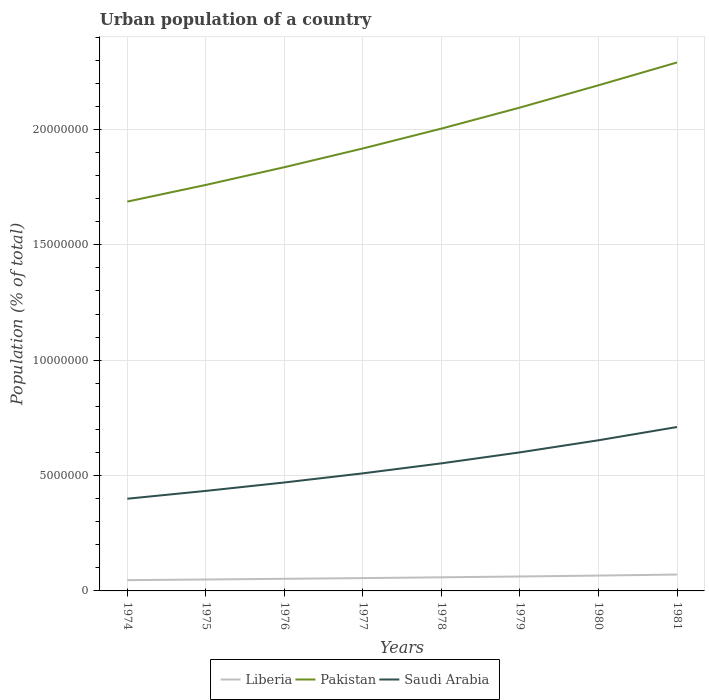How many different coloured lines are there?
Offer a terse response. 3. Does the line corresponding to Saudi Arabia intersect with the line corresponding to Pakistan?
Your answer should be compact. No. Is the number of lines equal to the number of legend labels?
Provide a short and direct response. Yes. Across all years, what is the maximum urban population in Liberia?
Make the answer very short. 4.66e+05. In which year was the urban population in Saudi Arabia maximum?
Your response must be concise. 1974. What is the total urban population in Saudi Arabia in the graph?
Make the answer very short. -7.61e+05. What is the difference between the highest and the second highest urban population in Pakistan?
Give a very brief answer. 6.03e+06. What is the difference between the highest and the lowest urban population in Saudi Arabia?
Ensure brevity in your answer.  4. Is the urban population in Liberia strictly greater than the urban population in Pakistan over the years?
Provide a short and direct response. Yes. How many years are there in the graph?
Offer a terse response. 8. What is the difference between two consecutive major ticks on the Y-axis?
Give a very brief answer. 5.00e+06. Are the values on the major ticks of Y-axis written in scientific E-notation?
Provide a short and direct response. No. Does the graph contain any zero values?
Provide a succinct answer. No. Where does the legend appear in the graph?
Your answer should be very brief. Bottom center. How many legend labels are there?
Your response must be concise. 3. How are the legend labels stacked?
Offer a very short reply. Horizontal. What is the title of the graph?
Your answer should be very brief. Urban population of a country. Does "Sweden" appear as one of the legend labels in the graph?
Provide a short and direct response. No. What is the label or title of the X-axis?
Keep it short and to the point. Years. What is the label or title of the Y-axis?
Offer a very short reply. Population (% of total). What is the Population (% of total) of Liberia in 1974?
Provide a short and direct response. 4.66e+05. What is the Population (% of total) of Pakistan in 1974?
Provide a succinct answer. 1.69e+07. What is the Population (% of total) in Saudi Arabia in 1974?
Keep it short and to the point. 4.00e+06. What is the Population (% of total) of Liberia in 1975?
Offer a very short reply. 4.95e+05. What is the Population (% of total) of Pakistan in 1975?
Make the answer very short. 1.76e+07. What is the Population (% of total) of Saudi Arabia in 1975?
Your response must be concise. 4.33e+06. What is the Population (% of total) of Liberia in 1976?
Offer a very short reply. 5.25e+05. What is the Population (% of total) in Pakistan in 1976?
Give a very brief answer. 1.84e+07. What is the Population (% of total) in Saudi Arabia in 1976?
Offer a very short reply. 4.70e+06. What is the Population (% of total) in Liberia in 1977?
Give a very brief answer. 5.56e+05. What is the Population (% of total) in Pakistan in 1977?
Offer a terse response. 1.92e+07. What is the Population (% of total) in Saudi Arabia in 1977?
Provide a succinct answer. 5.10e+06. What is the Population (% of total) in Liberia in 1978?
Your answer should be compact. 5.90e+05. What is the Population (% of total) of Pakistan in 1978?
Give a very brief answer. 2.00e+07. What is the Population (% of total) of Saudi Arabia in 1978?
Ensure brevity in your answer.  5.53e+06. What is the Population (% of total) in Liberia in 1979?
Your answer should be very brief. 6.26e+05. What is the Population (% of total) of Pakistan in 1979?
Give a very brief answer. 2.09e+07. What is the Population (% of total) in Saudi Arabia in 1979?
Your response must be concise. 6.00e+06. What is the Population (% of total) of Liberia in 1980?
Keep it short and to the point. 6.66e+05. What is the Population (% of total) of Pakistan in 1980?
Offer a terse response. 2.19e+07. What is the Population (% of total) of Saudi Arabia in 1980?
Make the answer very short. 6.53e+06. What is the Population (% of total) of Liberia in 1981?
Give a very brief answer. 7.09e+05. What is the Population (% of total) in Pakistan in 1981?
Your response must be concise. 2.29e+07. What is the Population (% of total) in Saudi Arabia in 1981?
Make the answer very short. 7.10e+06. Across all years, what is the maximum Population (% of total) in Liberia?
Your response must be concise. 7.09e+05. Across all years, what is the maximum Population (% of total) of Pakistan?
Offer a very short reply. 2.29e+07. Across all years, what is the maximum Population (% of total) of Saudi Arabia?
Make the answer very short. 7.10e+06. Across all years, what is the minimum Population (% of total) of Liberia?
Provide a succinct answer. 4.66e+05. Across all years, what is the minimum Population (% of total) of Pakistan?
Offer a very short reply. 1.69e+07. Across all years, what is the minimum Population (% of total) of Saudi Arabia?
Your response must be concise. 4.00e+06. What is the total Population (% of total) in Liberia in the graph?
Ensure brevity in your answer.  4.63e+06. What is the total Population (% of total) in Pakistan in the graph?
Provide a succinct answer. 1.58e+08. What is the total Population (% of total) in Saudi Arabia in the graph?
Your response must be concise. 4.33e+07. What is the difference between the Population (% of total) in Liberia in 1974 and that in 1975?
Offer a very short reply. -2.84e+04. What is the difference between the Population (% of total) in Pakistan in 1974 and that in 1975?
Offer a very short reply. -7.23e+05. What is the difference between the Population (% of total) in Saudi Arabia in 1974 and that in 1975?
Your answer should be very brief. -3.40e+05. What is the difference between the Population (% of total) in Liberia in 1974 and that in 1976?
Provide a succinct answer. -5.84e+04. What is the difference between the Population (% of total) of Pakistan in 1974 and that in 1976?
Offer a terse response. -1.49e+06. What is the difference between the Population (% of total) in Saudi Arabia in 1974 and that in 1976?
Your answer should be compact. -7.04e+05. What is the difference between the Population (% of total) of Liberia in 1974 and that in 1977?
Give a very brief answer. -8.97e+04. What is the difference between the Population (% of total) of Pakistan in 1974 and that in 1977?
Make the answer very short. -2.30e+06. What is the difference between the Population (% of total) in Saudi Arabia in 1974 and that in 1977?
Your answer should be very brief. -1.10e+06. What is the difference between the Population (% of total) in Liberia in 1974 and that in 1978?
Provide a succinct answer. -1.23e+05. What is the difference between the Population (% of total) of Pakistan in 1974 and that in 1978?
Keep it short and to the point. -3.16e+06. What is the difference between the Population (% of total) of Saudi Arabia in 1974 and that in 1978?
Offer a very short reply. -1.53e+06. What is the difference between the Population (% of total) of Liberia in 1974 and that in 1979?
Provide a short and direct response. -1.59e+05. What is the difference between the Population (% of total) in Pakistan in 1974 and that in 1979?
Provide a short and direct response. -4.08e+06. What is the difference between the Population (% of total) in Saudi Arabia in 1974 and that in 1979?
Provide a short and direct response. -2.01e+06. What is the difference between the Population (% of total) in Liberia in 1974 and that in 1980?
Offer a terse response. -1.99e+05. What is the difference between the Population (% of total) in Pakistan in 1974 and that in 1980?
Keep it short and to the point. -5.04e+06. What is the difference between the Population (% of total) in Saudi Arabia in 1974 and that in 1980?
Your answer should be compact. -2.53e+06. What is the difference between the Population (% of total) in Liberia in 1974 and that in 1981?
Offer a terse response. -2.43e+05. What is the difference between the Population (% of total) of Pakistan in 1974 and that in 1981?
Offer a very short reply. -6.03e+06. What is the difference between the Population (% of total) of Saudi Arabia in 1974 and that in 1981?
Your response must be concise. -3.11e+06. What is the difference between the Population (% of total) of Liberia in 1975 and that in 1976?
Make the answer very short. -3.00e+04. What is the difference between the Population (% of total) of Pakistan in 1975 and that in 1976?
Offer a very short reply. -7.68e+05. What is the difference between the Population (% of total) in Saudi Arabia in 1975 and that in 1976?
Provide a short and direct response. -3.65e+05. What is the difference between the Population (% of total) of Liberia in 1975 and that in 1977?
Make the answer very short. -6.13e+04. What is the difference between the Population (% of total) in Pakistan in 1975 and that in 1977?
Ensure brevity in your answer.  -1.58e+06. What is the difference between the Population (% of total) in Saudi Arabia in 1975 and that in 1977?
Your response must be concise. -7.61e+05. What is the difference between the Population (% of total) in Liberia in 1975 and that in 1978?
Give a very brief answer. -9.47e+04. What is the difference between the Population (% of total) of Pakistan in 1975 and that in 1978?
Provide a succinct answer. -2.44e+06. What is the difference between the Population (% of total) of Saudi Arabia in 1975 and that in 1978?
Your answer should be very brief. -1.19e+06. What is the difference between the Population (% of total) of Liberia in 1975 and that in 1979?
Offer a terse response. -1.31e+05. What is the difference between the Population (% of total) in Pakistan in 1975 and that in 1979?
Keep it short and to the point. -3.35e+06. What is the difference between the Population (% of total) of Saudi Arabia in 1975 and that in 1979?
Make the answer very short. -1.67e+06. What is the difference between the Population (% of total) in Liberia in 1975 and that in 1980?
Offer a terse response. -1.71e+05. What is the difference between the Population (% of total) in Pakistan in 1975 and that in 1980?
Offer a very short reply. -4.32e+06. What is the difference between the Population (% of total) in Saudi Arabia in 1975 and that in 1980?
Your answer should be compact. -2.19e+06. What is the difference between the Population (% of total) in Liberia in 1975 and that in 1981?
Your answer should be very brief. -2.15e+05. What is the difference between the Population (% of total) in Pakistan in 1975 and that in 1981?
Give a very brief answer. -5.31e+06. What is the difference between the Population (% of total) in Saudi Arabia in 1975 and that in 1981?
Provide a short and direct response. -2.77e+06. What is the difference between the Population (% of total) in Liberia in 1976 and that in 1977?
Offer a terse response. -3.13e+04. What is the difference between the Population (% of total) in Pakistan in 1976 and that in 1977?
Ensure brevity in your answer.  -8.12e+05. What is the difference between the Population (% of total) of Saudi Arabia in 1976 and that in 1977?
Offer a terse response. -3.96e+05. What is the difference between the Population (% of total) of Liberia in 1976 and that in 1978?
Give a very brief answer. -6.47e+04. What is the difference between the Population (% of total) of Pakistan in 1976 and that in 1978?
Your answer should be compact. -1.67e+06. What is the difference between the Population (% of total) of Saudi Arabia in 1976 and that in 1978?
Your response must be concise. -8.29e+05. What is the difference between the Population (% of total) in Liberia in 1976 and that in 1979?
Make the answer very short. -1.01e+05. What is the difference between the Population (% of total) in Pakistan in 1976 and that in 1979?
Provide a short and direct response. -2.58e+06. What is the difference between the Population (% of total) of Saudi Arabia in 1976 and that in 1979?
Your answer should be very brief. -1.31e+06. What is the difference between the Population (% of total) in Liberia in 1976 and that in 1980?
Give a very brief answer. -1.41e+05. What is the difference between the Population (% of total) in Pakistan in 1976 and that in 1980?
Keep it short and to the point. -3.55e+06. What is the difference between the Population (% of total) in Saudi Arabia in 1976 and that in 1980?
Give a very brief answer. -1.83e+06. What is the difference between the Population (% of total) in Liberia in 1976 and that in 1981?
Offer a very short reply. -1.85e+05. What is the difference between the Population (% of total) in Pakistan in 1976 and that in 1981?
Your answer should be compact. -4.54e+06. What is the difference between the Population (% of total) in Saudi Arabia in 1976 and that in 1981?
Provide a short and direct response. -2.40e+06. What is the difference between the Population (% of total) of Liberia in 1977 and that in 1978?
Ensure brevity in your answer.  -3.34e+04. What is the difference between the Population (% of total) in Pakistan in 1977 and that in 1978?
Keep it short and to the point. -8.61e+05. What is the difference between the Population (% of total) in Saudi Arabia in 1977 and that in 1978?
Provide a short and direct response. -4.33e+05. What is the difference between the Population (% of total) of Liberia in 1977 and that in 1979?
Provide a succinct answer. -6.97e+04. What is the difference between the Population (% of total) in Pakistan in 1977 and that in 1979?
Offer a terse response. -1.77e+06. What is the difference between the Population (% of total) of Saudi Arabia in 1977 and that in 1979?
Offer a very short reply. -9.10e+05. What is the difference between the Population (% of total) in Liberia in 1977 and that in 1980?
Offer a very short reply. -1.09e+05. What is the difference between the Population (% of total) of Pakistan in 1977 and that in 1980?
Make the answer very short. -2.74e+06. What is the difference between the Population (% of total) of Saudi Arabia in 1977 and that in 1980?
Offer a terse response. -1.43e+06. What is the difference between the Population (% of total) of Liberia in 1977 and that in 1981?
Give a very brief answer. -1.53e+05. What is the difference between the Population (% of total) of Pakistan in 1977 and that in 1981?
Give a very brief answer. -3.73e+06. What is the difference between the Population (% of total) of Saudi Arabia in 1977 and that in 1981?
Provide a succinct answer. -2.01e+06. What is the difference between the Population (% of total) of Liberia in 1978 and that in 1979?
Make the answer very short. -3.63e+04. What is the difference between the Population (% of total) in Pakistan in 1978 and that in 1979?
Your response must be concise. -9.11e+05. What is the difference between the Population (% of total) in Saudi Arabia in 1978 and that in 1979?
Keep it short and to the point. -4.76e+05. What is the difference between the Population (% of total) of Liberia in 1978 and that in 1980?
Keep it short and to the point. -7.60e+04. What is the difference between the Population (% of total) of Pakistan in 1978 and that in 1980?
Provide a succinct answer. -1.88e+06. What is the difference between the Population (% of total) of Saudi Arabia in 1978 and that in 1980?
Your answer should be compact. -1.00e+06. What is the difference between the Population (% of total) of Liberia in 1978 and that in 1981?
Keep it short and to the point. -1.20e+05. What is the difference between the Population (% of total) of Pakistan in 1978 and that in 1981?
Keep it short and to the point. -2.87e+06. What is the difference between the Population (% of total) of Saudi Arabia in 1978 and that in 1981?
Ensure brevity in your answer.  -1.57e+06. What is the difference between the Population (% of total) of Liberia in 1979 and that in 1980?
Provide a succinct answer. -3.97e+04. What is the difference between the Population (% of total) in Pakistan in 1979 and that in 1980?
Keep it short and to the point. -9.66e+05. What is the difference between the Population (% of total) in Saudi Arabia in 1979 and that in 1980?
Your response must be concise. -5.24e+05. What is the difference between the Population (% of total) of Liberia in 1979 and that in 1981?
Offer a terse response. -8.36e+04. What is the difference between the Population (% of total) of Pakistan in 1979 and that in 1981?
Give a very brief answer. -1.95e+06. What is the difference between the Population (% of total) in Saudi Arabia in 1979 and that in 1981?
Your answer should be very brief. -1.10e+06. What is the difference between the Population (% of total) in Liberia in 1980 and that in 1981?
Provide a short and direct response. -4.39e+04. What is the difference between the Population (% of total) in Pakistan in 1980 and that in 1981?
Offer a very short reply. -9.89e+05. What is the difference between the Population (% of total) of Saudi Arabia in 1980 and that in 1981?
Provide a succinct answer. -5.74e+05. What is the difference between the Population (% of total) of Liberia in 1974 and the Population (% of total) of Pakistan in 1975?
Offer a very short reply. -1.71e+07. What is the difference between the Population (% of total) of Liberia in 1974 and the Population (% of total) of Saudi Arabia in 1975?
Offer a terse response. -3.87e+06. What is the difference between the Population (% of total) in Pakistan in 1974 and the Population (% of total) in Saudi Arabia in 1975?
Ensure brevity in your answer.  1.25e+07. What is the difference between the Population (% of total) of Liberia in 1974 and the Population (% of total) of Pakistan in 1976?
Your answer should be compact. -1.79e+07. What is the difference between the Population (% of total) in Liberia in 1974 and the Population (% of total) in Saudi Arabia in 1976?
Your answer should be compact. -4.23e+06. What is the difference between the Population (% of total) of Pakistan in 1974 and the Population (% of total) of Saudi Arabia in 1976?
Keep it short and to the point. 1.22e+07. What is the difference between the Population (% of total) of Liberia in 1974 and the Population (% of total) of Pakistan in 1977?
Offer a very short reply. -1.87e+07. What is the difference between the Population (% of total) in Liberia in 1974 and the Population (% of total) in Saudi Arabia in 1977?
Offer a very short reply. -4.63e+06. What is the difference between the Population (% of total) in Pakistan in 1974 and the Population (% of total) in Saudi Arabia in 1977?
Provide a succinct answer. 1.18e+07. What is the difference between the Population (% of total) of Liberia in 1974 and the Population (% of total) of Pakistan in 1978?
Offer a terse response. -1.96e+07. What is the difference between the Population (% of total) in Liberia in 1974 and the Population (% of total) in Saudi Arabia in 1978?
Give a very brief answer. -5.06e+06. What is the difference between the Population (% of total) in Pakistan in 1974 and the Population (% of total) in Saudi Arabia in 1978?
Ensure brevity in your answer.  1.13e+07. What is the difference between the Population (% of total) in Liberia in 1974 and the Population (% of total) in Pakistan in 1979?
Ensure brevity in your answer.  -2.05e+07. What is the difference between the Population (% of total) in Liberia in 1974 and the Population (% of total) in Saudi Arabia in 1979?
Keep it short and to the point. -5.54e+06. What is the difference between the Population (% of total) of Pakistan in 1974 and the Population (% of total) of Saudi Arabia in 1979?
Offer a terse response. 1.09e+07. What is the difference between the Population (% of total) of Liberia in 1974 and the Population (% of total) of Pakistan in 1980?
Your answer should be very brief. -2.14e+07. What is the difference between the Population (% of total) in Liberia in 1974 and the Population (% of total) in Saudi Arabia in 1980?
Make the answer very short. -6.06e+06. What is the difference between the Population (% of total) in Pakistan in 1974 and the Population (% of total) in Saudi Arabia in 1980?
Provide a short and direct response. 1.03e+07. What is the difference between the Population (% of total) in Liberia in 1974 and the Population (% of total) in Pakistan in 1981?
Give a very brief answer. -2.24e+07. What is the difference between the Population (% of total) of Liberia in 1974 and the Population (% of total) of Saudi Arabia in 1981?
Offer a terse response. -6.64e+06. What is the difference between the Population (% of total) in Pakistan in 1974 and the Population (% of total) in Saudi Arabia in 1981?
Your response must be concise. 9.77e+06. What is the difference between the Population (% of total) in Liberia in 1975 and the Population (% of total) in Pakistan in 1976?
Offer a very short reply. -1.79e+07. What is the difference between the Population (% of total) in Liberia in 1975 and the Population (% of total) in Saudi Arabia in 1976?
Keep it short and to the point. -4.20e+06. What is the difference between the Population (% of total) of Pakistan in 1975 and the Population (% of total) of Saudi Arabia in 1976?
Provide a succinct answer. 1.29e+07. What is the difference between the Population (% of total) in Liberia in 1975 and the Population (% of total) in Pakistan in 1977?
Your answer should be compact. -1.87e+07. What is the difference between the Population (% of total) in Liberia in 1975 and the Population (% of total) in Saudi Arabia in 1977?
Ensure brevity in your answer.  -4.60e+06. What is the difference between the Population (% of total) in Pakistan in 1975 and the Population (% of total) in Saudi Arabia in 1977?
Give a very brief answer. 1.25e+07. What is the difference between the Population (% of total) of Liberia in 1975 and the Population (% of total) of Pakistan in 1978?
Give a very brief answer. -1.95e+07. What is the difference between the Population (% of total) of Liberia in 1975 and the Population (% of total) of Saudi Arabia in 1978?
Offer a very short reply. -5.03e+06. What is the difference between the Population (% of total) of Pakistan in 1975 and the Population (% of total) of Saudi Arabia in 1978?
Provide a short and direct response. 1.21e+07. What is the difference between the Population (% of total) in Liberia in 1975 and the Population (% of total) in Pakistan in 1979?
Your answer should be very brief. -2.05e+07. What is the difference between the Population (% of total) in Liberia in 1975 and the Population (% of total) in Saudi Arabia in 1979?
Your answer should be compact. -5.51e+06. What is the difference between the Population (% of total) of Pakistan in 1975 and the Population (% of total) of Saudi Arabia in 1979?
Offer a very short reply. 1.16e+07. What is the difference between the Population (% of total) in Liberia in 1975 and the Population (% of total) in Pakistan in 1980?
Ensure brevity in your answer.  -2.14e+07. What is the difference between the Population (% of total) in Liberia in 1975 and the Population (% of total) in Saudi Arabia in 1980?
Provide a succinct answer. -6.03e+06. What is the difference between the Population (% of total) of Pakistan in 1975 and the Population (% of total) of Saudi Arabia in 1980?
Your response must be concise. 1.11e+07. What is the difference between the Population (% of total) in Liberia in 1975 and the Population (% of total) in Pakistan in 1981?
Your answer should be very brief. -2.24e+07. What is the difference between the Population (% of total) in Liberia in 1975 and the Population (% of total) in Saudi Arabia in 1981?
Ensure brevity in your answer.  -6.61e+06. What is the difference between the Population (% of total) of Pakistan in 1975 and the Population (% of total) of Saudi Arabia in 1981?
Provide a short and direct response. 1.05e+07. What is the difference between the Population (% of total) of Liberia in 1976 and the Population (% of total) of Pakistan in 1977?
Your answer should be very brief. -1.86e+07. What is the difference between the Population (% of total) of Liberia in 1976 and the Population (% of total) of Saudi Arabia in 1977?
Offer a terse response. -4.57e+06. What is the difference between the Population (% of total) of Pakistan in 1976 and the Population (% of total) of Saudi Arabia in 1977?
Offer a very short reply. 1.33e+07. What is the difference between the Population (% of total) in Liberia in 1976 and the Population (% of total) in Pakistan in 1978?
Keep it short and to the point. -1.95e+07. What is the difference between the Population (% of total) in Liberia in 1976 and the Population (% of total) in Saudi Arabia in 1978?
Give a very brief answer. -5.00e+06. What is the difference between the Population (% of total) in Pakistan in 1976 and the Population (% of total) in Saudi Arabia in 1978?
Provide a short and direct response. 1.28e+07. What is the difference between the Population (% of total) of Liberia in 1976 and the Population (% of total) of Pakistan in 1979?
Make the answer very short. -2.04e+07. What is the difference between the Population (% of total) in Liberia in 1976 and the Population (% of total) in Saudi Arabia in 1979?
Keep it short and to the point. -5.48e+06. What is the difference between the Population (% of total) in Pakistan in 1976 and the Population (% of total) in Saudi Arabia in 1979?
Your answer should be compact. 1.24e+07. What is the difference between the Population (% of total) of Liberia in 1976 and the Population (% of total) of Pakistan in 1980?
Offer a terse response. -2.14e+07. What is the difference between the Population (% of total) in Liberia in 1976 and the Population (% of total) in Saudi Arabia in 1980?
Offer a terse response. -6.00e+06. What is the difference between the Population (% of total) in Pakistan in 1976 and the Population (% of total) in Saudi Arabia in 1980?
Give a very brief answer. 1.18e+07. What is the difference between the Population (% of total) of Liberia in 1976 and the Population (% of total) of Pakistan in 1981?
Provide a short and direct response. -2.24e+07. What is the difference between the Population (% of total) in Liberia in 1976 and the Population (% of total) in Saudi Arabia in 1981?
Make the answer very short. -6.58e+06. What is the difference between the Population (% of total) in Pakistan in 1976 and the Population (% of total) in Saudi Arabia in 1981?
Keep it short and to the point. 1.13e+07. What is the difference between the Population (% of total) of Liberia in 1977 and the Population (% of total) of Pakistan in 1978?
Offer a terse response. -1.95e+07. What is the difference between the Population (% of total) in Liberia in 1977 and the Population (% of total) in Saudi Arabia in 1978?
Provide a succinct answer. -4.97e+06. What is the difference between the Population (% of total) in Pakistan in 1977 and the Population (% of total) in Saudi Arabia in 1978?
Offer a very short reply. 1.36e+07. What is the difference between the Population (% of total) in Liberia in 1977 and the Population (% of total) in Pakistan in 1979?
Give a very brief answer. -2.04e+07. What is the difference between the Population (% of total) in Liberia in 1977 and the Population (% of total) in Saudi Arabia in 1979?
Your answer should be very brief. -5.45e+06. What is the difference between the Population (% of total) in Pakistan in 1977 and the Population (% of total) in Saudi Arabia in 1979?
Keep it short and to the point. 1.32e+07. What is the difference between the Population (% of total) of Liberia in 1977 and the Population (% of total) of Pakistan in 1980?
Offer a very short reply. -2.14e+07. What is the difference between the Population (% of total) of Liberia in 1977 and the Population (% of total) of Saudi Arabia in 1980?
Your answer should be compact. -5.97e+06. What is the difference between the Population (% of total) of Pakistan in 1977 and the Population (% of total) of Saudi Arabia in 1980?
Offer a very short reply. 1.26e+07. What is the difference between the Population (% of total) of Liberia in 1977 and the Population (% of total) of Pakistan in 1981?
Make the answer very short. -2.23e+07. What is the difference between the Population (% of total) of Liberia in 1977 and the Population (% of total) of Saudi Arabia in 1981?
Keep it short and to the point. -6.55e+06. What is the difference between the Population (% of total) of Pakistan in 1977 and the Population (% of total) of Saudi Arabia in 1981?
Provide a short and direct response. 1.21e+07. What is the difference between the Population (% of total) in Liberia in 1978 and the Population (% of total) in Pakistan in 1979?
Ensure brevity in your answer.  -2.04e+07. What is the difference between the Population (% of total) of Liberia in 1978 and the Population (% of total) of Saudi Arabia in 1979?
Your answer should be compact. -5.42e+06. What is the difference between the Population (% of total) in Pakistan in 1978 and the Population (% of total) in Saudi Arabia in 1979?
Give a very brief answer. 1.40e+07. What is the difference between the Population (% of total) of Liberia in 1978 and the Population (% of total) of Pakistan in 1980?
Keep it short and to the point. -2.13e+07. What is the difference between the Population (% of total) in Liberia in 1978 and the Population (% of total) in Saudi Arabia in 1980?
Give a very brief answer. -5.94e+06. What is the difference between the Population (% of total) of Pakistan in 1978 and the Population (% of total) of Saudi Arabia in 1980?
Keep it short and to the point. 1.35e+07. What is the difference between the Population (% of total) in Liberia in 1978 and the Population (% of total) in Pakistan in 1981?
Your answer should be very brief. -2.23e+07. What is the difference between the Population (% of total) of Liberia in 1978 and the Population (% of total) of Saudi Arabia in 1981?
Offer a terse response. -6.51e+06. What is the difference between the Population (% of total) in Pakistan in 1978 and the Population (% of total) in Saudi Arabia in 1981?
Provide a succinct answer. 1.29e+07. What is the difference between the Population (% of total) of Liberia in 1979 and the Population (% of total) of Pakistan in 1980?
Your answer should be compact. -2.13e+07. What is the difference between the Population (% of total) of Liberia in 1979 and the Population (% of total) of Saudi Arabia in 1980?
Ensure brevity in your answer.  -5.90e+06. What is the difference between the Population (% of total) of Pakistan in 1979 and the Population (% of total) of Saudi Arabia in 1980?
Make the answer very short. 1.44e+07. What is the difference between the Population (% of total) of Liberia in 1979 and the Population (% of total) of Pakistan in 1981?
Your answer should be compact. -2.23e+07. What is the difference between the Population (% of total) of Liberia in 1979 and the Population (% of total) of Saudi Arabia in 1981?
Your answer should be compact. -6.48e+06. What is the difference between the Population (% of total) of Pakistan in 1979 and the Population (% of total) of Saudi Arabia in 1981?
Provide a succinct answer. 1.38e+07. What is the difference between the Population (% of total) in Liberia in 1980 and the Population (% of total) in Pakistan in 1981?
Keep it short and to the point. -2.22e+07. What is the difference between the Population (% of total) in Liberia in 1980 and the Population (% of total) in Saudi Arabia in 1981?
Your response must be concise. -6.44e+06. What is the difference between the Population (% of total) in Pakistan in 1980 and the Population (% of total) in Saudi Arabia in 1981?
Your answer should be compact. 1.48e+07. What is the average Population (% of total) of Liberia per year?
Your answer should be very brief. 5.79e+05. What is the average Population (% of total) in Pakistan per year?
Your response must be concise. 1.97e+07. What is the average Population (% of total) in Saudi Arabia per year?
Make the answer very short. 5.41e+06. In the year 1974, what is the difference between the Population (% of total) of Liberia and Population (% of total) of Pakistan?
Offer a very short reply. -1.64e+07. In the year 1974, what is the difference between the Population (% of total) in Liberia and Population (% of total) in Saudi Arabia?
Provide a short and direct response. -3.53e+06. In the year 1974, what is the difference between the Population (% of total) in Pakistan and Population (% of total) in Saudi Arabia?
Offer a very short reply. 1.29e+07. In the year 1975, what is the difference between the Population (% of total) in Liberia and Population (% of total) in Pakistan?
Offer a very short reply. -1.71e+07. In the year 1975, what is the difference between the Population (% of total) of Liberia and Population (% of total) of Saudi Arabia?
Offer a very short reply. -3.84e+06. In the year 1975, what is the difference between the Population (% of total) of Pakistan and Population (% of total) of Saudi Arabia?
Give a very brief answer. 1.33e+07. In the year 1976, what is the difference between the Population (% of total) of Liberia and Population (% of total) of Pakistan?
Offer a terse response. -1.78e+07. In the year 1976, what is the difference between the Population (% of total) in Liberia and Population (% of total) in Saudi Arabia?
Your answer should be very brief. -4.17e+06. In the year 1976, what is the difference between the Population (% of total) of Pakistan and Population (% of total) of Saudi Arabia?
Give a very brief answer. 1.37e+07. In the year 1977, what is the difference between the Population (% of total) of Liberia and Population (% of total) of Pakistan?
Make the answer very short. -1.86e+07. In the year 1977, what is the difference between the Population (% of total) of Liberia and Population (% of total) of Saudi Arabia?
Give a very brief answer. -4.54e+06. In the year 1977, what is the difference between the Population (% of total) in Pakistan and Population (% of total) in Saudi Arabia?
Offer a very short reply. 1.41e+07. In the year 1978, what is the difference between the Population (% of total) in Liberia and Population (% of total) in Pakistan?
Make the answer very short. -1.94e+07. In the year 1978, what is the difference between the Population (% of total) of Liberia and Population (% of total) of Saudi Arabia?
Offer a very short reply. -4.94e+06. In the year 1978, what is the difference between the Population (% of total) in Pakistan and Population (% of total) in Saudi Arabia?
Ensure brevity in your answer.  1.45e+07. In the year 1979, what is the difference between the Population (% of total) in Liberia and Population (% of total) in Pakistan?
Keep it short and to the point. -2.03e+07. In the year 1979, what is the difference between the Population (% of total) of Liberia and Population (% of total) of Saudi Arabia?
Offer a terse response. -5.38e+06. In the year 1979, what is the difference between the Population (% of total) of Pakistan and Population (% of total) of Saudi Arabia?
Offer a very short reply. 1.49e+07. In the year 1980, what is the difference between the Population (% of total) in Liberia and Population (% of total) in Pakistan?
Make the answer very short. -2.12e+07. In the year 1980, what is the difference between the Population (% of total) in Liberia and Population (% of total) in Saudi Arabia?
Your response must be concise. -5.86e+06. In the year 1980, what is the difference between the Population (% of total) of Pakistan and Population (% of total) of Saudi Arabia?
Your response must be concise. 1.54e+07. In the year 1981, what is the difference between the Population (% of total) of Liberia and Population (% of total) of Pakistan?
Offer a terse response. -2.22e+07. In the year 1981, what is the difference between the Population (% of total) of Liberia and Population (% of total) of Saudi Arabia?
Your answer should be compact. -6.39e+06. In the year 1981, what is the difference between the Population (% of total) in Pakistan and Population (% of total) in Saudi Arabia?
Provide a succinct answer. 1.58e+07. What is the ratio of the Population (% of total) of Liberia in 1974 to that in 1975?
Your response must be concise. 0.94. What is the ratio of the Population (% of total) in Pakistan in 1974 to that in 1975?
Offer a terse response. 0.96. What is the ratio of the Population (% of total) in Saudi Arabia in 1974 to that in 1975?
Give a very brief answer. 0.92. What is the ratio of the Population (% of total) of Liberia in 1974 to that in 1976?
Keep it short and to the point. 0.89. What is the ratio of the Population (% of total) of Pakistan in 1974 to that in 1976?
Provide a short and direct response. 0.92. What is the ratio of the Population (% of total) in Saudi Arabia in 1974 to that in 1976?
Give a very brief answer. 0.85. What is the ratio of the Population (% of total) in Liberia in 1974 to that in 1977?
Your answer should be very brief. 0.84. What is the ratio of the Population (% of total) of Pakistan in 1974 to that in 1977?
Your answer should be very brief. 0.88. What is the ratio of the Population (% of total) in Saudi Arabia in 1974 to that in 1977?
Offer a terse response. 0.78. What is the ratio of the Population (% of total) in Liberia in 1974 to that in 1978?
Ensure brevity in your answer.  0.79. What is the ratio of the Population (% of total) in Pakistan in 1974 to that in 1978?
Your response must be concise. 0.84. What is the ratio of the Population (% of total) in Saudi Arabia in 1974 to that in 1978?
Your answer should be very brief. 0.72. What is the ratio of the Population (% of total) of Liberia in 1974 to that in 1979?
Keep it short and to the point. 0.75. What is the ratio of the Population (% of total) in Pakistan in 1974 to that in 1979?
Offer a very short reply. 0.81. What is the ratio of the Population (% of total) in Saudi Arabia in 1974 to that in 1979?
Offer a very short reply. 0.67. What is the ratio of the Population (% of total) of Liberia in 1974 to that in 1980?
Provide a short and direct response. 0.7. What is the ratio of the Population (% of total) in Pakistan in 1974 to that in 1980?
Provide a succinct answer. 0.77. What is the ratio of the Population (% of total) of Saudi Arabia in 1974 to that in 1980?
Your answer should be very brief. 0.61. What is the ratio of the Population (% of total) of Liberia in 1974 to that in 1981?
Your answer should be compact. 0.66. What is the ratio of the Population (% of total) of Pakistan in 1974 to that in 1981?
Make the answer very short. 0.74. What is the ratio of the Population (% of total) of Saudi Arabia in 1974 to that in 1981?
Your response must be concise. 0.56. What is the ratio of the Population (% of total) in Liberia in 1975 to that in 1976?
Keep it short and to the point. 0.94. What is the ratio of the Population (% of total) of Pakistan in 1975 to that in 1976?
Your response must be concise. 0.96. What is the ratio of the Population (% of total) of Saudi Arabia in 1975 to that in 1976?
Provide a short and direct response. 0.92. What is the ratio of the Population (% of total) of Liberia in 1975 to that in 1977?
Your answer should be compact. 0.89. What is the ratio of the Population (% of total) in Pakistan in 1975 to that in 1977?
Make the answer very short. 0.92. What is the ratio of the Population (% of total) in Saudi Arabia in 1975 to that in 1977?
Make the answer very short. 0.85. What is the ratio of the Population (% of total) in Liberia in 1975 to that in 1978?
Your response must be concise. 0.84. What is the ratio of the Population (% of total) of Pakistan in 1975 to that in 1978?
Provide a succinct answer. 0.88. What is the ratio of the Population (% of total) in Saudi Arabia in 1975 to that in 1978?
Keep it short and to the point. 0.78. What is the ratio of the Population (% of total) in Liberia in 1975 to that in 1979?
Offer a very short reply. 0.79. What is the ratio of the Population (% of total) of Pakistan in 1975 to that in 1979?
Offer a very short reply. 0.84. What is the ratio of the Population (% of total) of Saudi Arabia in 1975 to that in 1979?
Your answer should be very brief. 0.72. What is the ratio of the Population (% of total) of Liberia in 1975 to that in 1980?
Ensure brevity in your answer.  0.74. What is the ratio of the Population (% of total) in Pakistan in 1975 to that in 1980?
Offer a very short reply. 0.8. What is the ratio of the Population (% of total) of Saudi Arabia in 1975 to that in 1980?
Your response must be concise. 0.66. What is the ratio of the Population (% of total) in Liberia in 1975 to that in 1981?
Give a very brief answer. 0.7. What is the ratio of the Population (% of total) of Pakistan in 1975 to that in 1981?
Provide a succinct answer. 0.77. What is the ratio of the Population (% of total) of Saudi Arabia in 1975 to that in 1981?
Offer a terse response. 0.61. What is the ratio of the Population (% of total) of Liberia in 1976 to that in 1977?
Provide a succinct answer. 0.94. What is the ratio of the Population (% of total) in Pakistan in 1976 to that in 1977?
Provide a succinct answer. 0.96. What is the ratio of the Population (% of total) of Saudi Arabia in 1976 to that in 1977?
Give a very brief answer. 0.92. What is the ratio of the Population (% of total) of Liberia in 1976 to that in 1978?
Your response must be concise. 0.89. What is the ratio of the Population (% of total) of Pakistan in 1976 to that in 1978?
Offer a very short reply. 0.92. What is the ratio of the Population (% of total) of Liberia in 1976 to that in 1979?
Offer a terse response. 0.84. What is the ratio of the Population (% of total) of Pakistan in 1976 to that in 1979?
Your answer should be very brief. 0.88. What is the ratio of the Population (% of total) in Saudi Arabia in 1976 to that in 1979?
Your answer should be compact. 0.78. What is the ratio of the Population (% of total) of Liberia in 1976 to that in 1980?
Offer a terse response. 0.79. What is the ratio of the Population (% of total) of Pakistan in 1976 to that in 1980?
Provide a short and direct response. 0.84. What is the ratio of the Population (% of total) of Saudi Arabia in 1976 to that in 1980?
Offer a very short reply. 0.72. What is the ratio of the Population (% of total) in Liberia in 1976 to that in 1981?
Offer a terse response. 0.74. What is the ratio of the Population (% of total) of Pakistan in 1976 to that in 1981?
Keep it short and to the point. 0.8. What is the ratio of the Population (% of total) in Saudi Arabia in 1976 to that in 1981?
Make the answer very short. 0.66. What is the ratio of the Population (% of total) in Liberia in 1977 to that in 1978?
Your answer should be compact. 0.94. What is the ratio of the Population (% of total) of Saudi Arabia in 1977 to that in 1978?
Make the answer very short. 0.92. What is the ratio of the Population (% of total) in Liberia in 1977 to that in 1979?
Provide a succinct answer. 0.89. What is the ratio of the Population (% of total) of Pakistan in 1977 to that in 1979?
Keep it short and to the point. 0.92. What is the ratio of the Population (% of total) of Saudi Arabia in 1977 to that in 1979?
Keep it short and to the point. 0.85. What is the ratio of the Population (% of total) of Liberia in 1977 to that in 1980?
Your answer should be very brief. 0.84. What is the ratio of the Population (% of total) in Pakistan in 1977 to that in 1980?
Offer a very short reply. 0.88. What is the ratio of the Population (% of total) of Saudi Arabia in 1977 to that in 1980?
Make the answer very short. 0.78. What is the ratio of the Population (% of total) of Liberia in 1977 to that in 1981?
Offer a very short reply. 0.78. What is the ratio of the Population (% of total) of Pakistan in 1977 to that in 1981?
Your response must be concise. 0.84. What is the ratio of the Population (% of total) of Saudi Arabia in 1977 to that in 1981?
Your answer should be very brief. 0.72. What is the ratio of the Population (% of total) in Liberia in 1978 to that in 1979?
Ensure brevity in your answer.  0.94. What is the ratio of the Population (% of total) in Pakistan in 1978 to that in 1979?
Ensure brevity in your answer.  0.96. What is the ratio of the Population (% of total) in Saudi Arabia in 1978 to that in 1979?
Give a very brief answer. 0.92. What is the ratio of the Population (% of total) of Liberia in 1978 to that in 1980?
Ensure brevity in your answer.  0.89. What is the ratio of the Population (% of total) of Pakistan in 1978 to that in 1980?
Keep it short and to the point. 0.91. What is the ratio of the Population (% of total) of Saudi Arabia in 1978 to that in 1980?
Give a very brief answer. 0.85. What is the ratio of the Population (% of total) of Liberia in 1978 to that in 1981?
Offer a terse response. 0.83. What is the ratio of the Population (% of total) in Pakistan in 1978 to that in 1981?
Offer a very short reply. 0.87. What is the ratio of the Population (% of total) of Saudi Arabia in 1978 to that in 1981?
Provide a short and direct response. 0.78. What is the ratio of the Population (% of total) in Liberia in 1979 to that in 1980?
Provide a succinct answer. 0.94. What is the ratio of the Population (% of total) of Pakistan in 1979 to that in 1980?
Your answer should be compact. 0.96. What is the ratio of the Population (% of total) of Saudi Arabia in 1979 to that in 1980?
Give a very brief answer. 0.92. What is the ratio of the Population (% of total) in Liberia in 1979 to that in 1981?
Offer a terse response. 0.88. What is the ratio of the Population (% of total) of Pakistan in 1979 to that in 1981?
Give a very brief answer. 0.91. What is the ratio of the Population (% of total) of Saudi Arabia in 1979 to that in 1981?
Give a very brief answer. 0.85. What is the ratio of the Population (% of total) in Liberia in 1980 to that in 1981?
Provide a short and direct response. 0.94. What is the ratio of the Population (% of total) of Pakistan in 1980 to that in 1981?
Your answer should be compact. 0.96. What is the ratio of the Population (% of total) in Saudi Arabia in 1980 to that in 1981?
Give a very brief answer. 0.92. What is the difference between the highest and the second highest Population (% of total) of Liberia?
Offer a very short reply. 4.39e+04. What is the difference between the highest and the second highest Population (% of total) in Pakistan?
Ensure brevity in your answer.  9.89e+05. What is the difference between the highest and the second highest Population (% of total) of Saudi Arabia?
Give a very brief answer. 5.74e+05. What is the difference between the highest and the lowest Population (% of total) of Liberia?
Your response must be concise. 2.43e+05. What is the difference between the highest and the lowest Population (% of total) of Pakistan?
Make the answer very short. 6.03e+06. What is the difference between the highest and the lowest Population (% of total) of Saudi Arabia?
Your answer should be very brief. 3.11e+06. 